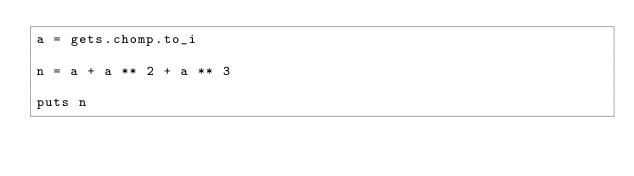<code> <loc_0><loc_0><loc_500><loc_500><_Ruby_>a = gets.chomp.to_i

n = a + a ** 2 + a ** 3

puts n
</code> 